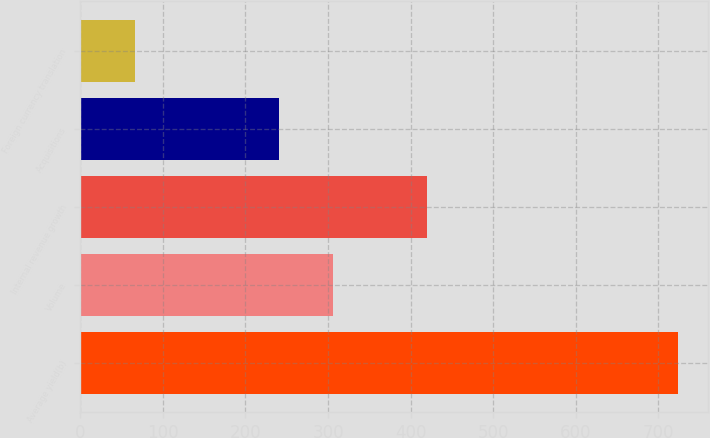<chart> <loc_0><loc_0><loc_500><loc_500><bar_chart><fcel>Average yield(b)<fcel>Volume<fcel>Internal revenue growth<fcel>Acquisitions<fcel>Foreign currency translation<nl><fcel>724<fcel>305.8<fcel>420<fcel>240<fcel>66<nl></chart> 